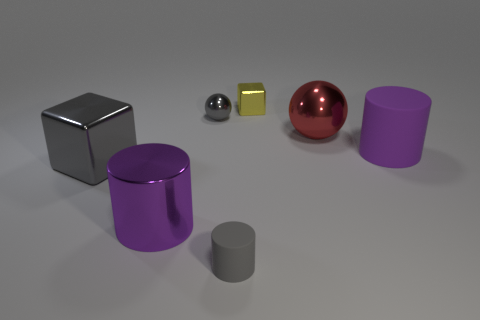Are there more purple matte objects that are on the right side of the gray ball than small brown cylinders?
Your answer should be compact. Yes. There is a large purple object that is made of the same material as the big sphere; what shape is it?
Ensure brevity in your answer.  Cylinder. There is a rubber thing that is in front of the metal cube that is in front of the purple rubber cylinder; what color is it?
Give a very brief answer. Gray. Is the big matte object the same shape as the large purple metal thing?
Give a very brief answer. Yes. What is the material of the red thing that is the same shape as the small gray metal object?
Ensure brevity in your answer.  Metal. There is a purple thing that is behind the gray cube on the left side of the small gray matte cylinder; is there a rubber cylinder in front of it?
Offer a terse response. Yes. Does the big red thing have the same shape as the matte thing in front of the big purple metal cylinder?
Provide a short and direct response. No. Is there any other thing that has the same color as the large ball?
Give a very brief answer. No. There is a matte thing that is in front of the big gray thing; does it have the same color as the block that is on the left side of the small block?
Make the answer very short. Yes. Are there any cyan balls?
Give a very brief answer. No. 